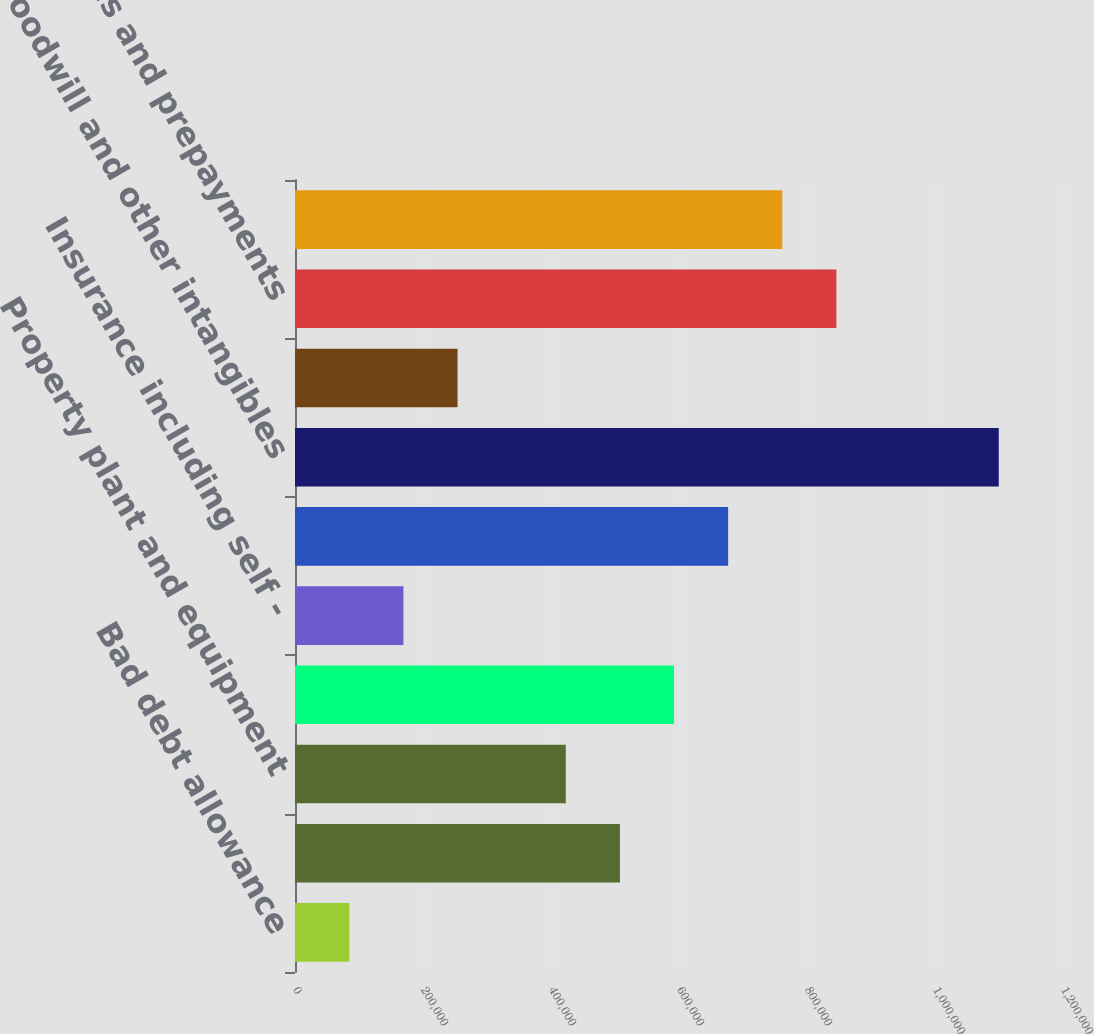Convert chart to OTSL. <chart><loc_0><loc_0><loc_500><loc_500><bar_chart><fcel>Bad debt allowance<fcel>Inventories<fcel>Property plant and equipment<fcel>Pension and postretirement<fcel>Insurance including self -<fcel>Basis difference in LYONs<fcel>Goodwill and other intangibles<fcel>Environmental and regulatory<fcel>Other accruals and prepayments<fcel>Deferred service income<nl><fcel>84846.1<fcel>507662<fcel>423098<fcel>592225<fcel>169409<fcel>676788<fcel>1.0996e+06<fcel>253972<fcel>845914<fcel>761351<nl></chart> 